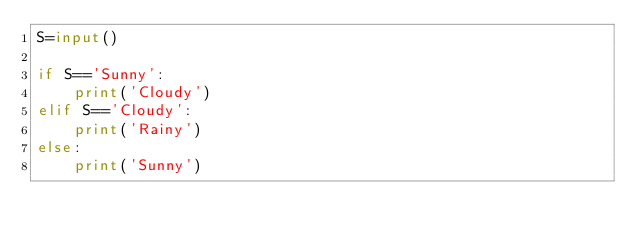Convert code to text. <code><loc_0><loc_0><loc_500><loc_500><_Python_>S=input()

if S=='Sunny':
    print('Cloudy')
elif S=='Cloudy':
    print('Rainy')
else:
    print('Sunny')</code> 